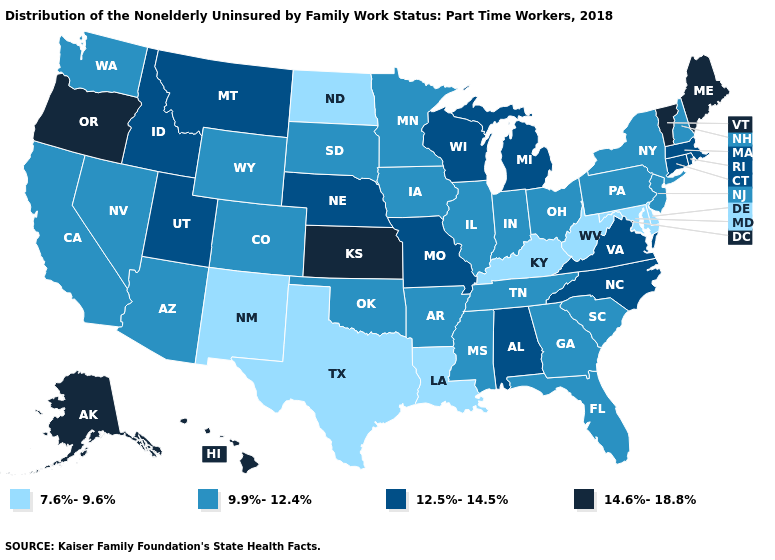What is the value of Mississippi?
Keep it brief. 9.9%-12.4%. What is the value of West Virginia?
Give a very brief answer. 7.6%-9.6%. Among the states that border New Mexico , does Utah have the highest value?
Write a very short answer. Yes. What is the value of Florida?
Be succinct. 9.9%-12.4%. What is the value of West Virginia?
Concise answer only. 7.6%-9.6%. Does Iowa have a lower value than New York?
Write a very short answer. No. Name the states that have a value in the range 7.6%-9.6%?
Short answer required. Delaware, Kentucky, Louisiana, Maryland, New Mexico, North Dakota, Texas, West Virginia. Among the states that border South Dakota , which have the highest value?
Give a very brief answer. Montana, Nebraska. Does Alaska have a lower value than Minnesota?
Short answer required. No. What is the highest value in states that border Iowa?
Quick response, please. 12.5%-14.5%. Does the map have missing data?
Short answer required. No. What is the highest value in states that border West Virginia?
Give a very brief answer. 12.5%-14.5%. Name the states that have a value in the range 14.6%-18.8%?
Keep it brief. Alaska, Hawaii, Kansas, Maine, Oregon, Vermont. What is the highest value in states that border West Virginia?
Concise answer only. 12.5%-14.5%. What is the value of Hawaii?
Answer briefly. 14.6%-18.8%. 